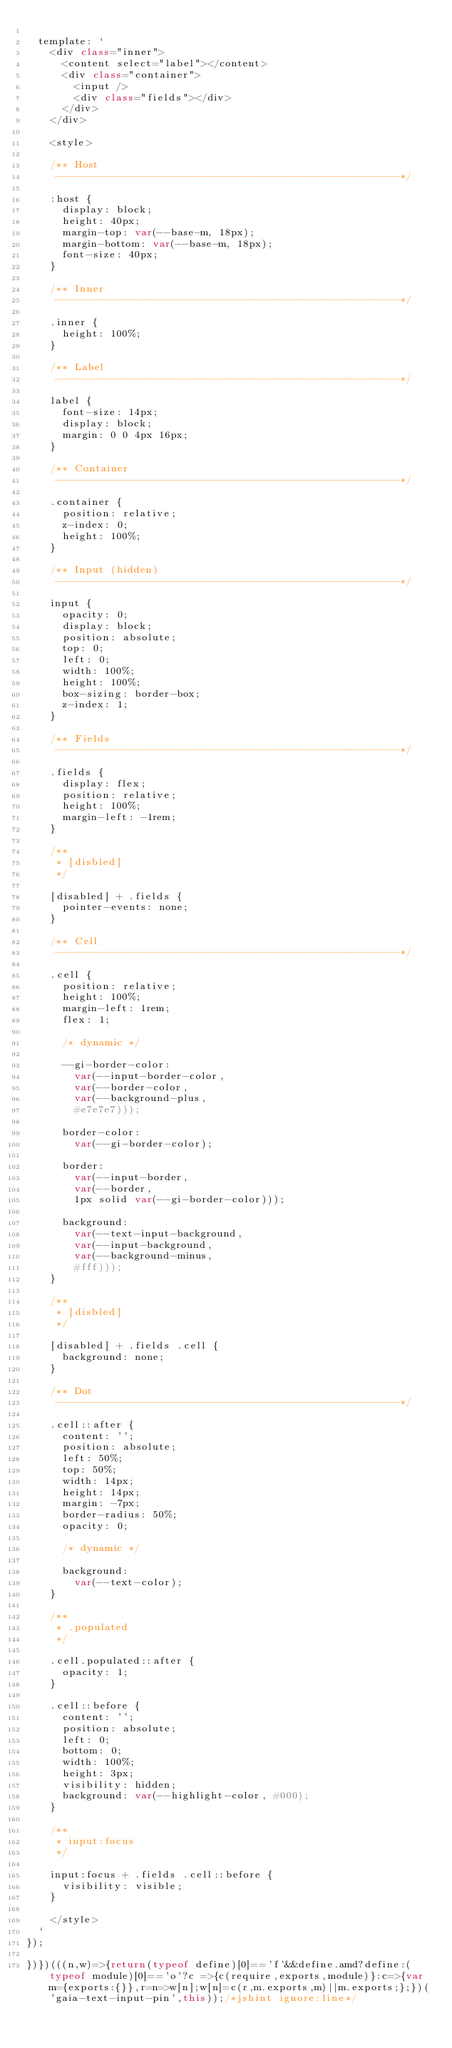<code> <loc_0><loc_0><loc_500><loc_500><_JavaScript_>
  template: `
    <div class="inner">
      <content select="label"></content>
      <div class="container">
        <input />
        <div class="fields"></div>
      </div>
    </div>

    <style>

    /** Host
     ---------------------------------------------------------*/

    :host {
      display: block;
      height: 40px;
      margin-top: var(--base-m, 18px);
      margin-bottom: var(--base-m, 18px);
      font-size: 40px;
    }

    /** Inner
     ---------------------------------------------------------*/

    .inner {
      height: 100%;
    }

    /** Label
     ---------------------------------------------------------*/

    label {
      font-size: 14px;
      display: block;
      margin: 0 0 4px 16px;
    }

    /** Container
     ---------------------------------------------------------*/

    .container {
      position: relative;
      z-index: 0;
      height: 100%;
    }

    /** Input (hidden)
     ---------------------------------------------------------*/

    input {
      opacity: 0;
      display: block;
      position: absolute;
      top: 0;
      left: 0;
      width: 100%;
      height: 100%;
      box-sizing: border-box;
      z-index: 1;
    }

    /** Fields
     ---------------------------------------------------------*/

    .fields {
      display: flex;
      position: relative;
      height: 100%;
      margin-left: -1rem;
    }

    /**
     * [disbled]
     */

    [disabled] + .fields {
      pointer-events: none;
    }

    /** Cell
     ---------------------------------------------------------*/

    .cell {
      position: relative;
      height: 100%;
      margin-left: 1rem;
      flex: 1;

      /* dynamic */

      --gi-border-color:
        var(--input-border-color,
        var(--border-color,
        var(--background-plus,
        #e7e7e7)));

      border-color:
        var(--gi-border-color);

      border:
        var(--input-border,
        var(--border,
        1px solid var(--gi-border-color)));

      background:
        var(--text-input-background,
        var(--input-background,
        var(--background-minus,
        #fff)));
    }

    /**
     * [disbled]
     */

    [disabled] + .fields .cell {
      background: none;
    }

    /** Dot
     ---------------------------------------------------------*/

    .cell::after {
      content: '';
      position: absolute;
      left: 50%;
      top: 50%;
      width: 14px;
      height: 14px;
      margin: -7px;
      border-radius: 50%;
      opacity: 0;

      /* dynamic */

      background:
        var(--text-color);
    }

    /**
     * .populated
     */

    .cell.populated::after {
      opacity: 1;
    }

    .cell::before {
      content: '';
      position: absolute;
      left: 0;
      bottom: 0;
      width: 100%;
      height: 3px;
      visibility: hidden;
      background: var(--highlight-color, #000);
    }

    /**
     * input:focus
     */

    input:focus + .fields .cell::before {
      visibility: visible;
    }

    </style>
  `
});

})})(((n,w)=>{return(typeof define)[0]=='f'&&define.amd?define:(typeof module)[0]=='o'?c =>{c(require,exports,module)}:c=>{var m={exports:{}},r=n=>w[n];w[n]=c(r,m.exports,m)||m.exports;};})('gaia-text-input-pin',this));/*jshint ignore:line*/</code> 